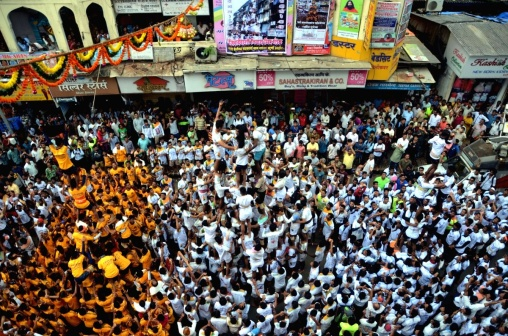Can you describe the types of clothing people are wearing at this event? Certainly! The individuals in the image are mainly dressed in white tops, suggesting a uniformed approach, likely for a sense of unity or participation in the event. Many are also wearing orange accessories, like turbans or scarves, which add vibrant color to the sea of white and might indicate the colors of a particular festival or celebration theme. 